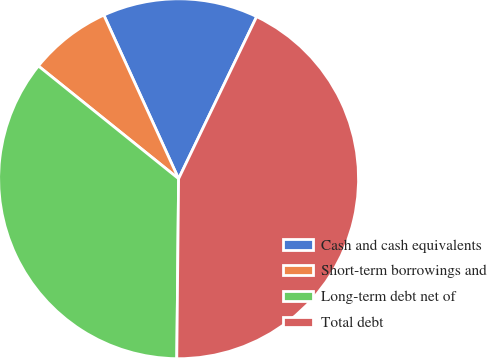Convert chart. <chart><loc_0><loc_0><loc_500><loc_500><pie_chart><fcel>Cash and cash equivalents<fcel>Short-term borrowings and<fcel>Long-term debt net of<fcel>Total debt<nl><fcel>13.96%<fcel>7.4%<fcel>35.62%<fcel>43.02%<nl></chart> 